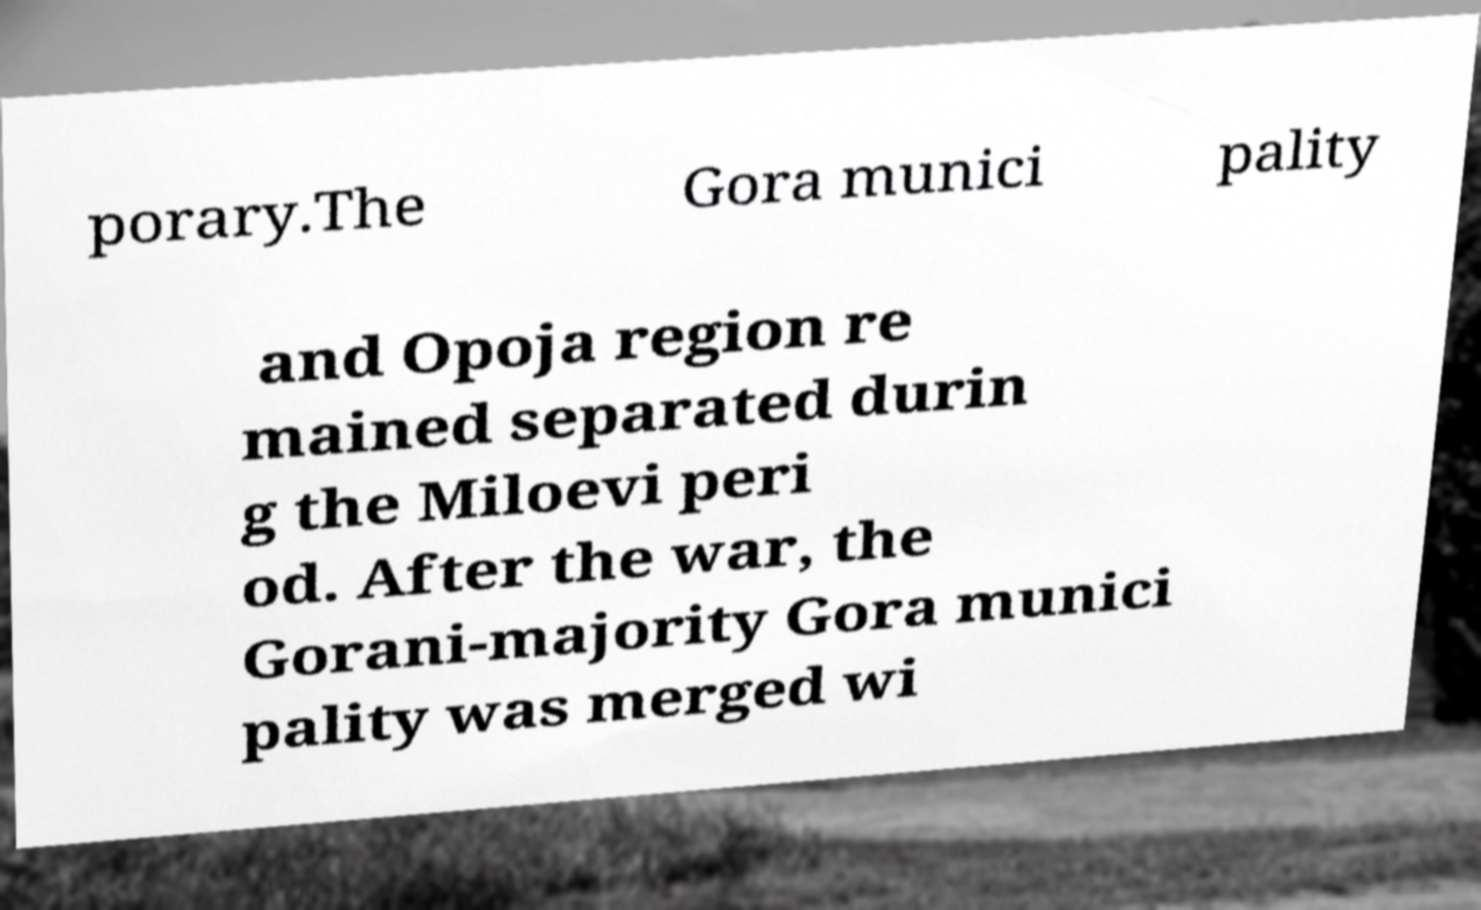Could you assist in decoding the text presented in this image and type it out clearly? porary.The Gora munici pality and Opoja region re mained separated durin g the Miloevi peri od. After the war, the Gorani-majority Gora munici pality was merged wi 